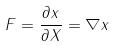<formula> <loc_0><loc_0><loc_500><loc_500>F = \frac { \partial x } { \partial X } = \nabla x</formula> 